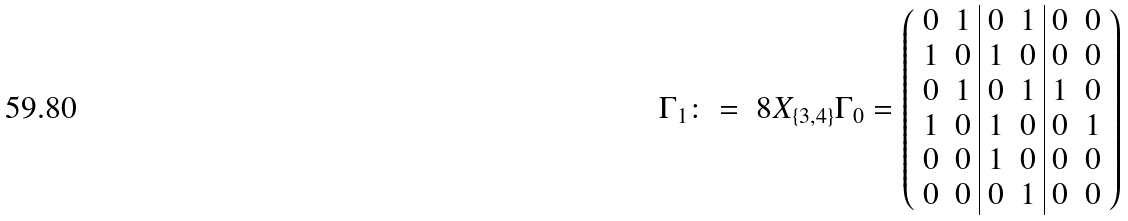Convert formula to latex. <formula><loc_0><loc_0><loc_500><loc_500>\Gamma _ { 1 } \colon = \ 8 X _ { \{ 3 , 4 \} } \Gamma _ { 0 } = \left ( \begin{array} { c c | c c | c c } 0 & 1 & 0 & 1 & 0 & 0 \\ 1 & 0 & 1 & 0 & 0 & 0 \\ 0 & 1 & 0 & 1 & 1 & 0 \\ 1 & 0 & 1 & 0 & 0 & 1 \\ 0 & 0 & 1 & 0 & 0 & 0 \\ 0 & 0 & 0 & 1 & 0 & 0 \\ \end{array} \right )</formula> 